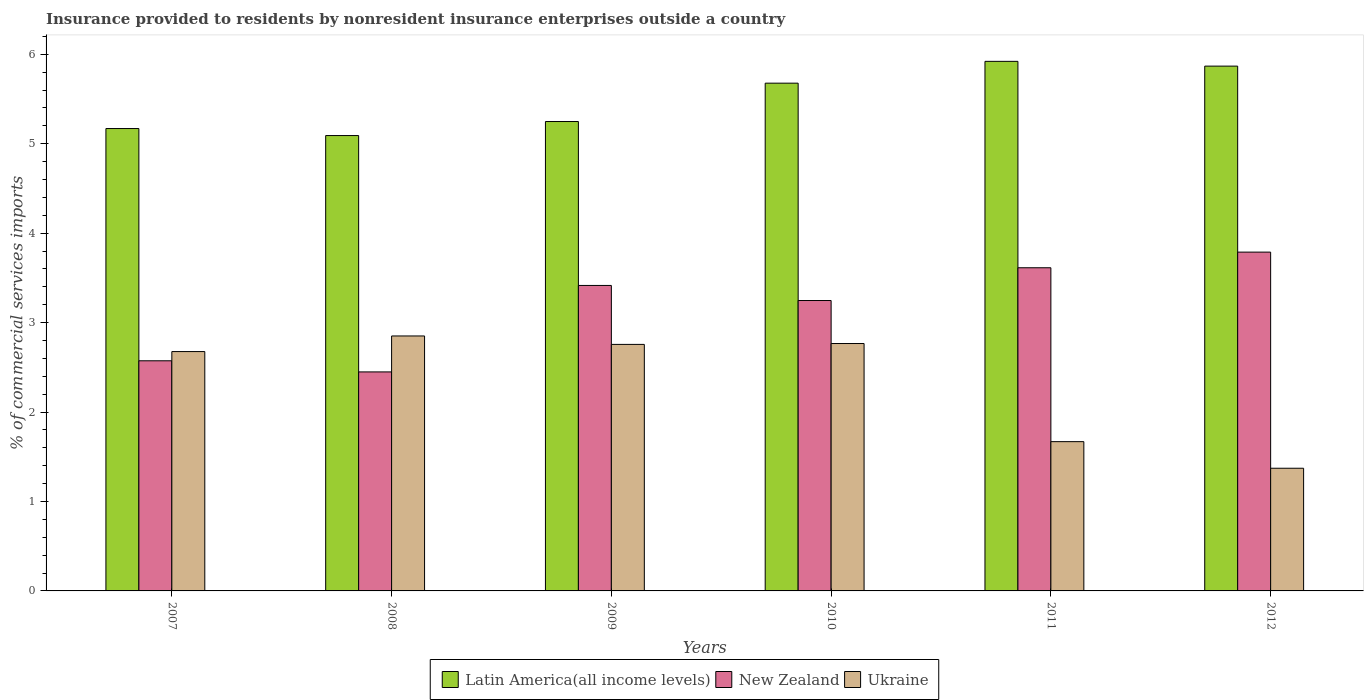How many bars are there on the 6th tick from the left?
Give a very brief answer. 3. In how many cases, is the number of bars for a given year not equal to the number of legend labels?
Ensure brevity in your answer.  0. What is the Insurance provided to residents in Latin America(all income levels) in 2011?
Keep it short and to the point. 5.92. Across all years, what is the maximum Insurance provided to residents in Latin America(all income levels)?
Offer a terse response. 5.92. Across all years, what is the minimum Insurance provided to residents in Latin America(all income levels)?
Your answer should be very brief. 5.09. In which year was the Insurance provided to residents in Ukraine minimum?
Your response must be concise. 2012. What is the total Insurance provided to residents in Latin America(all income levels) in the graph?
Provide a succinct answer. 32.98. What is the difference between the Insurance provided to residents in Latin America(all income levels) in 2010 and that in 2011?
Make the answer very short. -0.24. What is the difference between the Insurance provided to residents in Latin America(all income levels) in 2010 and the Insurance provided to residents in New Zealand in 2009?
Provide a succinct answer. 2.26. What is the average Insurance provided to residents in Ukraine per year?
Keep it short and to the point. 2.35. In the year 2008, what is the difference between the Insurance provided to residents in New Zealand and Insurance provided to residents in Latin America(all income levels)?
Ensure brevity in your answer.  -2.64. In how many years, is the Insurance provided to residents in New Zealand greater than 4.2 %?
Keep it short and to the point. 0. What is the ratio of the Insurance provided to residents in Ukraine in 2009 to that in 2010?
Keep it short and to the point. 1. Is the Insurance provided to residents in Ukraine in 2008 less than that in 2012?
Make the answer very short. No. Is the difference between the Insurance provided to residents in New Zealand in 2011 and 2012 greater than the difference between the Insurance provided to residents in Latin America(all income levels) in 2011 and 2012?
Your answer should be compact. No. What is the difference between the highest and the second highest Insurance provided to residents in Latin America(all income levels)?
Give a very brief answer. 0.05. What is the difference between the highest and the lowest Insurance provided to residents in Ukraine?
Offer a terse response. 1.48. In how many years, is the Insurance provided to residents in New Zealand greater than the average Insurance provided to residents in New Zealand taken over all years?
Offer a terse response. 4. What does the 3rd bar from the left in 2008 represents?
Provide a succinct answer. Ukraine. What does the 3rd bar from the right in 2010 represents?
Offer a terse response. Latin America(all income levels). Are all the bars in the graph horizontal?
Your answer should be compact. No. How many years are there in the graph?
Provide a short and direct response. 6. Are the values on the major ticks of Y-axis written in scientific E-notation?
Make the answer very short. No. How many legend labels are there?
Your answer should be very brief. 3. How are the legend labels stacked?
Your response must be concise. Horizontal. What is the title of the graph?
Give a very brief answer. Insurance provided to residents by nonresident insurance enterprises outside a country. What is the label or title of the Y-axis?
Offer a very short reply. % of commercial services imports. What is the % of commercial services imports in Latin America(all income levels) in 2007?
Provide a succinct answer. 5.17. What is the % of commercial services imports in New Zealand in 2007?
Keep it short and to the point. 2.57. What is the % of commercial services imports in Ukraine in 2007?
Offer a very short reply. 2.68. What is the % of commercial services imports of Latin America(all income levels) in 2008?
Keep it short and to the point. 5.09. What is the % of commercial services imports in New Zealand in 2008?
Make the answer very short. 2.45. What is the % of commercial services imports in Ukraine in 2008?
Ensure brevity in your answer.  2.85. What is the % of commercial services imports in Latin America(all income levels) in 2009?
Make the answer very short. 5.25. What is the % of commercial services imports of New Zealand in 2009?
Offer a very short reply. 3.42. What is the % of commercial services imports of Ukraine in 2009?
Your response must be concise. 2.76. What is the % of commercial services imports of Latin America(all income levels) in 2010?
Your answer should be compact. 5.68. What is the % of commercial services imports in New Zealand in 2010?
Offer a very short reply. 3.25. What is the % of commercial services imports in Ukraine in 2010?
Give a very brief answer. 2.77. What is the % of commercial services imports of Latin America(all income levels) in 2011?
Offer a very short reply. 5.92. What is the % of commercial services imports in New Zealand in 2011?
Keep it short and to the point. 3.61. What is the % of commercial services imports in Ukraine in 2011?
Ensure brevity in your answer.  1.67. What is the % of commercial services imports of Latin America(all income levels) in 2012?
Offer a very short reply. 5.87. What is the % of commercial services imports of New Zealand in 2012?
Make the answer very short. 3.79. What is the % of commercial services imports in Ukraine in 2012?
Provide a short and direct response. 1.37. Across all years, what is the maximum % of commercial services imports of Latin America(all income levels)?
Your answer should be very brief. 5.92. Across all years, what is the maximum % of commercial services imports of New Zealand?
Keep it short and to the point. 3.79. Across all years, what is the maximum % of commercial services imports in Ukraine?
Your answer should be very brief. 2.85. Across all years, what is the minimum % of commercial services imports of Latin America(all income levels)?
Keep it short and to the point. 5.09. Across all years, what is the minimum % of commercial services imports in New Zealand?
Provide a succinct answer. 2.45. Across all years, what is the minimum % of commercial services imports of Ukraine?
Give a very brief answer. 1.37. What is the total % of commercial services imports of Latin America(all income levels) in the graph?
Keep it short and to the point. 32.98. What is the total % of commercial services imports of New Zealand in the graph?
Give a very brief answer. 19.09. What is the total % of commercial services imports of Ukraine in the graph?
Offer a very short reply. 14.09. What is the difference between the % of commercial services imports of Latin America(all income levels) in 2007 and that in 2008?
Make the answer very short. 0.08. What is the difference between the % of commercial services imports in New Zealand in 2007 and that in 2008?
Offer a very short reply. 0.12. What is the difference between the % of commercial services imports of Ukraine in 2007 and that in 2008?
Offer a terse response. -0.17. What is the difference between the % of commercial services imports of Latin America(all income levels) in 2007 and that in 2009?
Ensure brevity in your answer.  -0.08. What is the difference between the % of commercial services imports in New Zealand in 2007 and that in 2009?
Your answer should be very brief. -0.84. What is the difference between the % of commercial services imports in Ukraine in 2007 and that in 2009?
Your response must be concise. -0.08. What is the difference between the % of commercial services imports of Latin America(all income levels) in 2007 and that in 2010?
Give a very brief answer. -0.51. What is the difference between the % of commercial services imports of New Zealand in 2007 and that in 2010?
Ensure brevity in your answer.  -0.67. What is the difference between the % of commercial services imports of Ukraine in 2007 and that in 2010?
Keep it short and to the point. -0.09. What is the difference between the % of commercial services imports in Latin America(all income levels) in 2007 and that in 2011?
Give a very brief answer. -0.75. What is the difference between the % of commercial services imports in New Zealand in 2007 and that in 2011?
Your answer should be very brief. -1.04. What is the difference between the % of commercial services imports of Ukraine in 2007 and that in 2011?
Keep it short and to the point. 1.01. What is the difference between the % of commercial services imports of Latin America(all income levels) in 2007 and that in 2012?
Your response must be concise. -0.7. What is the difference between the % of commercial services imports in New Zealand in 2007 and that in 2012?
Offer a very short reply. -1.22. What is the difference between the % of commercial services imports of Ukraine in 2007 and that in 2012?
Your response must be concise. 1.3. What is the difference between the % of commercial services imports in Latin America(all income levels) in 2008 and that in 2009?
Keep it short and to the point. -0.16. What is the difference between the % of commercial services imports in New Zealand in 2008 and that in 2009?
Make the answer very short. -0.97. What is the difference between the % of commercial services imports of Ukraine in 2008 and that in 2009?
Make the answer very short. 0.09. What is the difference between the % of commercial services imports of Latin America(all income levels) in 2008 and that in 2010?
Offer a very short reply. -0.59. What is the difference between the % of commercial services imports in New Zealand in 2008 and that in 2010?
Offer a terse response. -0.8. What is the difference between the % of commercial services imports of Ukraine in 2008 and that in 2010?
Your answer should be compact. 0.08. What is the difference between the % of commercial services imports in Latin America(all income levels) in 2008 and that in 2011?
Give a very brief answer. -0.83. What is the difference between the % of commercial services imports in New Zealand in 2008 and that in 2011?
Provide a succinct answer. -1.16. What is the difference between the % of commercial services imports of Ukraine in 2008 and that in 2011?
Provide a short and direct response. 1.18. What is the difference between the % of commercial services imports in Latin America(all income levels) in 2008 and that in 2012?
Your response must be concise. -0.78. What is the difference between the % of commercial services imports in New Zealand in 2008 and that in 2012?
Keep it short and to the point. -1.34. What is the difference between the % of commercial services imports in Ukraine in 2008 and that in 2012?
Give a very brief answer. 1.48. What is the difference between the % of commercial services imports of Latin America(all income levels) in 2009 and that in 2010?
Offer a terse response. -0.43. What is the difference between the % of commercial services imports in New Zealand in 2009 and that in 2010?
Ensure brevity in your answer.  0.17. What is the difference between the % of commercial services imports in Ukraine in 2009 and that in 2010?
Provide a succinct answer. -0.01. What is the difference between the % of commercial services imports of Latin America(all income levels) in 2009 and that in 2011?
Your answer should be compact. -0.67. What is the difference between the % of commercial services imports in New Zealand in 2009 and that in 2011?
Give a very brief answer. -0.2. What is the difference between the % of commercial services imports in Ukraine in 2009 and that in 2011?
Offer a very short reply. 1.09. What is the difference between the % of commercial services imports of Latin America(all income levels) in 2009 and that in 2012?
Your answer should be very brief. -0.62. What is the difference between the % of commercial services imports of New Zealand in 2009 and that in 2012?
Your answer should be very brief. -0.37. What is the difference between the % of commercial services imports in Ukraine in 2009 and that in 2012?
Make the answer very short. 1.38. What is the difference between the % of commercial services imports of Latin America(all income levels) in 2010 and that in 2011?
Offer a terse response. -0.24. What is the difference between the % of commercial services imports in New Zealand in 2010 and that in 2011?
Your response must be concise. -0.37. What is the difference between the % of commercial services imports of Ukraine in 2010 and that in 2011?
Offer a terse response. 1.1. What is the difference between the % of commercial services imports in Latin America(all income levels) in 2010 and that in 2012?
Provide a succinct answer. -0.19. What is the difference between the % of commercial services imports of New Zealand in 2010 and that in 2012?
Provide a short and direct response. -0.54. What is the difference between the % of commercial services imports in Ukraine in 2010 and that in 2012?
Provide a succinct answer. 1.39. What is the difference between the % of commercial services imports of Latin America(all income levels) in 2011 and that in 2012?
Your answer should be compact. 0.05. What is the difference between the % of commercial services imports in New Zealand in 2011 and that in 2012?
Your answer should be compact. -0.17. What is the difference between the % of commercial services imports in Ukraine in 2011 and that in 2012?
Give a very brief answer. 0.3. What is the difference between the % of commercial services imports in Latin America(all income levels) in 2007 and the % of commercial services imports in New Zealand in 2008?
Provide a short and direct response. 2.72. What is the difference between the % of commercial services imports in Latin America(all income levels) in 2007 and the % of commercial services imports in Ukraine in 2008?
Make the answer very short. 2.32. What is the difference between the % of commercial services imports of New Zealand in 2007 and the % of commercial services imports of Ukraine in 2008?
Ensure brevity in your answer.  -0.28. What is the difference between the % of commercial services imports in Latin America(all income levels) in 2007 and the % of commercial services imports in New Zealand in 2009?
Provide a short and direct response. 1.75. What is the difference between the % of commercial services imports in Latin America(all income levels) in 2007 and the % of commercial services imports in Ukraine in 2009?
Provide a short and direct response. 2.41. What is the difference between the % of commercial services imports of New Zealand in 2007 and the % of commercial services imports of Ukraine in 2009?
Your answer should be very brief. -0.18. What is the difference between the % of commercial services imports of Latin America(all income levels) in 2007 and the % of commercial services imports of New Zealand in 2010?
Keep it short and to the point. 1.92. What is the difference between the % of commercial services imports of Latin America(all income levels) in 2007 and the % of commercial services imports of Ukraine in 2010?
Ensure brevity in your answer.  2.4. What is the difference between the % of commercial services imports in New Zealand in 2007 and the % of commercial services imports in Ukraine in 2010?
Offer a terse response. -0.19. What is the difference between the % of commercial services imports of Latin America(all income levels) in 2007 and the % of commercial services imports of New Zealand in 2011?
Your answer should be very brief. 1.56. What is the difference between the % of commercial services imports of Latin America(all income levels) in 2007 and the % of commercial services imports of Ukraine in 2011?
Offer a terse response. 3.5. What is the difference between the % of commercial services imports in New Zealand in 2007 and the % of commercial services imports in Ukraine in 2011?
Provide a short and direct response. 0.9. What is the difference between the % of commercial services imports in Latin America(all income levels) in 2007 and the % of commercial services imports in New Zealand in 2012?
Make the answer very short. 1.38. What is the difference between the % of commercial services imports in Latin America(all income levels) in 2007 and the % of commercial services imports in Ukraine in 2012?
Your answer should be compact. 3.8. What is the difference between the % of commercial services imports in New Zealand in 2007 and the % of commercial services imports in Ukraine in 2012?
Your answer should be compact. 1.2. What is the difference between the % of commercial services imports in Latin America(all income levels) in 2008 and the % of commercial services imports in New Zealand in 2009?
Give a very brief answer. 1.68. What is the difference between the % of commercial services imports in Latin America(all income levels) in 2008 and the % of commercial services imports in Ukraine in 2009?
Provide a short and direct response. 2.34. What is the difference between the % of commercial services imports of New Zealand in 2008 and the % of commercial services imports of Ukraine in 2009?
Provide a short and direct response. -0.31. What is the difference between the % of commercial services imports of Latin America(all income levels) in 2008 and the % of commercial services imports of New Zealand in 2010?
Offer a terse response. 1.84. What is the difference between the % of commercial services imports in Latin America(all income levels) in 2008 and the % of commercial services imports in Ukraine in 2010?
Provide a short and direct response. 2.33. What is the difference between the % of commercial services imports of New Zealand in 2008 and the % of commercial services imports of Ukraine in 2010?
Make the answer very short. -0.32. What is the difference between the % of commercial services imports in Latin America(all income levels) in 2008 and the % of commercial services imports in New Zealand in 2011?
Offer a terse response. 1.48. What is the difference between the % of commercial services imports in Latin America(all income levels) in 2008 and the % of commercial services imports in Ukraine in 2011?
Give a very brief answer. 3.42. What is the difference between the % of commercial services imports of New Zealand in 2008 and the % of commercial services imports of Ukraine in 2011?
Your response must be concise. 0.78. What is the difference between the % of commercial services imports in Latin America(all income levels) in 2008 and the % of commercial services imports in New Zealand in 2012?
Provide a short and direct response. 1.3. What is the difference between the % of commercial services imports of Latin America(all income levels) in 2008 and the % of commercial services imports of Ukraine in 2012?
Your answer should be compact. 3.72. What is the difference between the % of commercial services imports of New Zealand in 2008 and the % of commercial services imports of Ukraine in 2012?
Keep it short and to the point. 1.08. What is the difference between the % of commercial services imports in Latin America(all income levels) in 2009 and the % of commercial services imports in New Zealand in 2010?
Your answer should be very brief. 2. What is the difference between the % of commercial services imports in Latin America(all income levels) in 2009 and the % of commercial services imports in Ukraine in 2010?
Provide a short and direct response. 2.48. What is the difference between the % of commercial services imports of New Zealand in 2009 and the % of commercial services imports of Ukraine in 2010?
Offer a very short reply. 0.65. What is the difference between the % of commercial services imports in Latin America(all income levels) in 2009 and the % of commercial services imports in New Zealand in 2011?
Give a very brief answer. 1.64. What is the difference between the % of commercial services imports in Latin America(all income levels) in 2009 and the % of commercial services imports in Ukraine in 2011?
Keep it short and to the point. 3.58. What is the difference between the % of commercial services imports of New Zealand in 2009 and the % of commercial services imports of Ukraine in 2011?
Your response must be concise. 1.75. What is the difference between the % of commercial services imports of Latin America(all income levels) in 2009 and the % of commercial services imports of New Zealand in 2012?
Your answer should be very brief. 1.46. What is the difference between the % of commercial services imports in Latin America(all income levels) in 2009 and the % of commercial services imports in Ukraine in 2012?
Offer a terse response. 3.88. What is the difference between the % of commercial services imports of New Zealand in 2009 and the % of commercial services imports of Ukraine in 2012?
Your answer should be compact. 2.04. What is the difference between the % of commercial services imports of Latin America(all income levels) in 2010 and the % of commercial services imports of New Zealand in 2011?
Make the answer very short. 2.06. What is the difference between the % of commercial services imports in Latin America(all income levels) in 2010 and the % of commercial services imports in Ukraine in 2011?
Your answer should be very brief. 4.01. What is the difference between the % of commercial services imports in New Zealand in 2010 and the % of commercial services imports in Ukraine in 2011?
Keep it short and to the point. 1.58. What is the difference between the % of commercial services imports in Latin America(all income levels) in 2010 and the % of commercial services imports in New Zealand in 2012?
Give a very brief answer. 1.89. What is the difference between the % of commercial services imports of Latin America(all income levels) in 2010 and the % of commercial services imports of Ukraine in 2012?
Your answer should be very brief. 4.31. What is the difference between the % of commercial services imports of New Zealand in 2010 and the % of commercial services imports of Ukraine in 2012?
Provide a short and direct response. 1.88. What is the difference between the % of commercial services imports of Latin America(all income levels) in 2011 and the % of commercial services imports of New Zealand in 2012?
Ensure brevity in your answer.  2.13. What is the difference between the % of commercial services imports in Latin America(all income levels) in 2011 and the % of commercial services imports in Ukraine in 2012?
Your response must be concise. 4.55. What is the difference between the % of commercial services imports in New Zealand in 2011 and the % of commercial services imports in Ukraine in 2012?
Provide a short and direct response. 2.24. What is the average % of commercial services imports in Latin America(all income levels) per year?
Offer a very short reply. 5.5. What is the average % of commercial services imports in New Zealand per year?
Your response must be concise. 3.18. What is the average % of commercial services imports in Ukraine per year?
Provide a short and direct response. 2.35. In the year 2007, what is the difference between the % of commercial services imports in Latin America(all income levels) and % of commercial services imports in New Zealand?
Keep it short and to the point. 2.6. In the year 2007, what is the difference between the % of commercial services imports in Latin America(all income levels) and % of commercial services imports in Ukraine?
Offer a very short reply. 2.49. In the year 2007, what is the difference between the % of commercial services imports of New Zealand and % of commercial services imports of Ukraine?
Keep it short and to the point. -0.1. In the year 2008, what is the difference between the % of commercial services imports of Latin America(all income levels) and % of commercial services imports of New Zealand?
Provide a short and direct response. 2.64. In the year 2008, what is the difference between the % of commercial services imports in Latin America(all income levels) and % of commercial services imports in Ukraine?
Ensure brevity in your answer.  2.24. In the year 2008, what is the difference between the % of commercial services imports in New Zealand and % of commercial services imports in Ukraine?
Your answer should be very brief. -0.4. In the year 2009, what is the difference between the % of commercial services imports in Latin America(all income levels) and % of commercial services imports in New Zealand?
Your answer should be very brief. 1.83. In the year 2009, what is the difference between the % of commercial services imports in Latin America(all income levels) and % of commercial services imports in Ukraine?
Ensure brevity in your answer.  2.49. In the year 2009, what is the difference between the % of commercial services imports in New Zealand and % of commercial services imports in Ukraine?
Your response must be concise. 0.66. In the year 2010, what is the difference between the % of commercial services imports in Latin America(all income levels) and % of commercial services imports in New Zealand?
Give a very brief answer. 2.43. In the year 2010, what is the difference between the % of commercial services imports in Latin America(all income levels) and % of commercial services imports in Ukraine?
Give a very brief answer. 2.91. In the year 2010, what is the difference between the % of commercial services imports of New Zealand and % of commercial services imports of Ukraine?
Your response must be concise. 0.48. In the year 2011, what is the difference between the % of commercial services imports of Latin America(all income levels) and % of commercial services imports of New Zealand?
Ensure brevity in your answer.  2.31. In the year 2011, what is the difference between the % of commercial services imports of Latin America(all income levels) and % of commercial services imports of Ukraine?
Offer a terse response. 4.25. In the year 2011, what is the difference between the % of commercial services imports of New Zealand and % of commercial services imports of Ukraine?
Your answer should be very brief. 1.94. In the year 2012, what is the difference between the % of commercial services imports of Latin America(all income levels) and % of commercial services imports of New Zealand?
Provide a succinct answer. 2.08. In the year 2012, what is the difference between the % of commercial services imports of Latin America(all income levels) and % of commercial services imports of Ukraine?
Offer a very short reply. 4.5. In the year 2012, what is the difference between the % of commercial services imports of New Zealand and % of commercial services imports of Ukraine?
Your answer should be compact. 2.42. What is the ratio of the % of commercial services imports of Latin America(all income levels) in 2007 to that in 2008?
Offer a very short reply. 1.02. What is the ratio of the % of commercial services imports in New Zealand in 2007 to that in 2008?
Provide a short and direct response. 1.05. What is the ratio of the % of commercial services imports in Ukraine in 2007 to that in 2008?
Keep it short and to the point. 0.94. What is the ratio of the % of commercial services imports of Latin America(all income levels) in 2007 to that in 2009?
Your answer should be very brief. 0.99. What is the ratio of the % of commercial services imports of New Zealand in 2007 to that in 2009?
Give a very brief answer. 0.75. What is the ratio of the % of commercial services imports in Ukraine in 2007 to that in 2009?
Keep it short and to the point. 0.97. What is the ratio of the % of commercial services imports of Latin America(all income levels) in 2007 to that in 2010?
Provide a succinct answer. 0.91. What is the ratio of the % of commercial services imports in New Zealand in 2007 to that in 2010?
Provide a succinct answer. 0.79. What is the ratio of the % of commercial services imports of Ukraine in 2007 to that in 2010?
Provide a short and direct response. 0.97. What is the ratio of the % of commercial services imports of Latin America(all income levels) in 2007 to that in 2011?
Give a very brief answer. 0.87. What is the ratio of the % of commercial services imports of New Zealand in 2007 to that in 2011?
Keep it short and to the point. 0.71. What is the ratio of the % of commercial services imports of Ukraine in 2007 to that in 2011?
Provide a short and direct response. 1.6. What is the ratio of the % of commercial services imports of Latin America(all income levels) in 2007 to that in 2012?
Your answer should be very brief. 0.88. What is the ratio of the % of commercial services imports of New Zealand in 2007 to that in 2012?
Your answer should be compact. 0.68. What is the ratio of the % of commercial services imports of Ukraine in 2007 to that in 2012?
Your answer should be very brief. 1.95. What is the ratio of the % of commercial services imports in Latin America(all income levels) in 2008 to that in 2009?
Ensure brevity in your answer.  0.97. What is the ratio of the % of commercial services imports of New Zealand in 2008 to that in 2009?
Make the answer very short. 0.72. What is the ratio of the % of commercial services imports in Ukraine in 2008 to that in 2009?
Your answer should be very brief. 1.03. What is the ratio of the % of commercial services imports in Latin America(all income levels) in 2008 to that in 2010?
Provide a succinct answer. 0.9. What is the ratio of the % of commercial services imports of New Zealand in 2008 to that in 2010?
Provide a succinct answer. 0.75. What is the ratio of the % of commercial services imports in Ukraine in 2008 to that in 2010?
Your answer should be very brief. 1.03. What is the ratio of the % of commercial services imports in Latin America(all income levels) in 2008 to that in 2011?
Your answer should be very brief. 0.86. What is the ratio of the % of commercial services imports of New Zealand in 2008 to that in 2011?
Your answer should be compact. 0.68. What is the ratio of the % of commercial services imports in Ukraine in 2008 to that in 2011?
Give a very brief answer. 1.71. What is the ratio of the % of commercial services imports of Latin America(all income levels) in 2008 to that in 2012?
Ensure brevity in your answer.  0.87. What is the ratio of the % of commercial services imports of New Zealand in 2008 to that in 2012?
Your answer should be very brief. 0.65. What is the ratio of the % of commercial services imports in Ukraine in 2008 to that in 2012?
Your answer should be compact. 2.08. What is the ratio of the % of commercial services imports in Latin America(all income levels) in 2009 to that in 2010?
Provide a succinct answer. 0.92. What is the ratio of the % of commercial services imports of New Zealand in 2009 to that in 2010?
Your answer should be compact. 1.05. What is the ratio of the % of commercial services imports in Latin America(all income levels) in 2009 to that in 2011?
Give a very brief answer. 0.89. What is the ratio of the % of commercial services imports in New Zealand in 2009 to that in 2011?
Your answer should be compact. 0.95. What is the ratio of the % of commercial services imports in Ukraine in 2009 to that in 2011?
Offer a terse response. 1.65. What is the ratio of the % of commercial services imports of Latin America(all income levels) in 2009 to that in 2012?
Make the answer very short. 0.89. What is the ratio of the % of commercial services imports in New Zealand in 2009 to that in 2012?
Your answer should be very brief. 0.9. What is the ratio of the % of commercial services imports in Ukraine in 2009 to that in 2012?
Offer a very short reply. 2.01. What is the ratio of the % of commercial services imports in Latin America(all income levels) in 2010 to that in 2011?
Make the answer very short. 0.96. What is the ratio of the % of commercial services imports in New Zealand in 2010 to that in 2011?
Keep it short and to the point. 0.9. What is the ratio of the % of commercial services imports in Ukraine in 2010 to that in 2011?
Give a very brief answer. 1.66. What is the ratio of the % of commercial services imports in Latin America(all income levels) in 2010 to that in 2012?
Ensure brevity in your answer.  0.97. What is the ratio of the % of commercial services imports of Ukraine in 2010 to that in 2012?
Provide a succinct answer. 2.02. What is the ratio of the % of commercial services imports in Latin America(all income levels) in 2011 to that in 2012?
Provide a succinct answer. 1.01. What is the ratio of the % of commercial services imports in New Zealand in 2011 to that in 2012?
Give a very brief answer. 0.95. What is the ratio of the % of commercial services imports of Ukraine in 2011 to that in 2012?
Offer a terse response. 1.22. What is the difference between the highest and the second highest % of commercial services imports in Latin America(all income levels)?
Offer a terse response. 0.05. What is the difference between the highest and the second highest % of commercial services imports in New Zealand?
Your answer should be very brief. 0.17. What is the difference between the highest and the second highest % of commercial services imports of Ukraine?
Your answer should be compact. 0.08. What is the difference between the highest and the lowest % of commercial services imports of Latin America(all income levels)?
Offer a terse response. 0.83. What is the difference between the highest and the lowest % of commercial services imports in New Zealand?
Offer a terse response. 1.34. What is the difference between the highest and the lowest % of commercial services imports of Ukraine?
Provide a succinct answer. 1.48. 